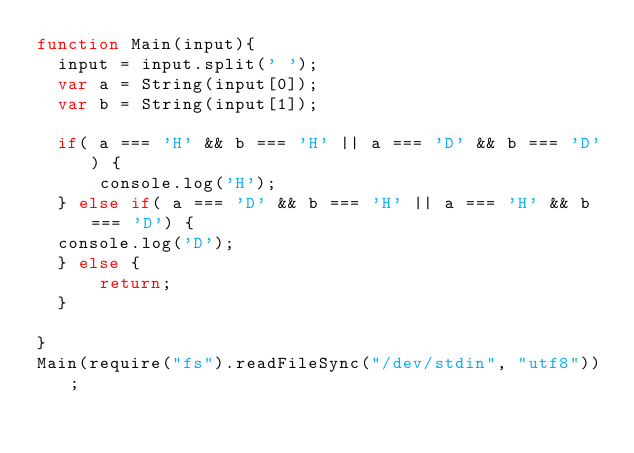<code> <loc_0><loc_0><loc_500><loc_500><_JavaScript_>function Main(input){
  input = input.split(' ');
  var a = String(input[0]);
  var b = String(input[1]);

  if( a === 'H' && b === 'H' || a === 'D' && b === 'D') {
      console.log('H');
  } else if( a === 'D' && b === 'H' || a === 'H' && b === 'D') {
  console.log('D');
  } else {
      return;
  }

}
Main(require("fs").readFileSync("/dev/stdin", "utf8"));</code> 